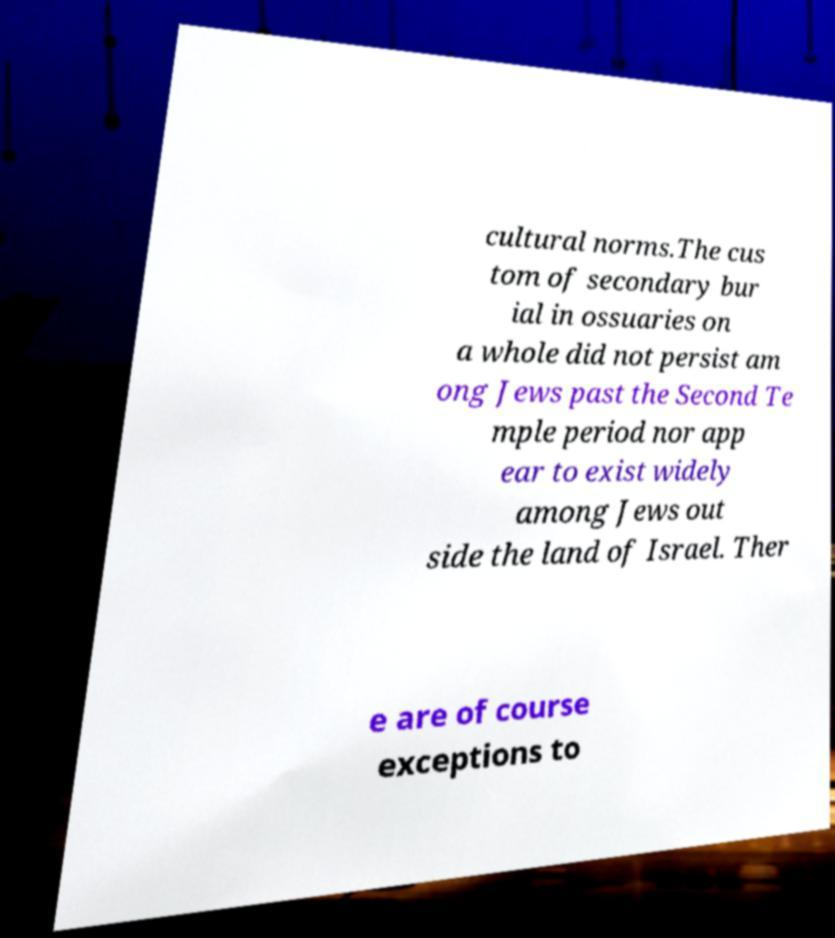I need the written content from this picture converted into text. Can you do that? cultural norms.The cus tom of secondary bur ial in ossuaries on a whole did not persist am ong Jews past the Second Te mple period nor app ear to exist widely among Jews out side the land of Israel. Ther e are of course exceptions to 